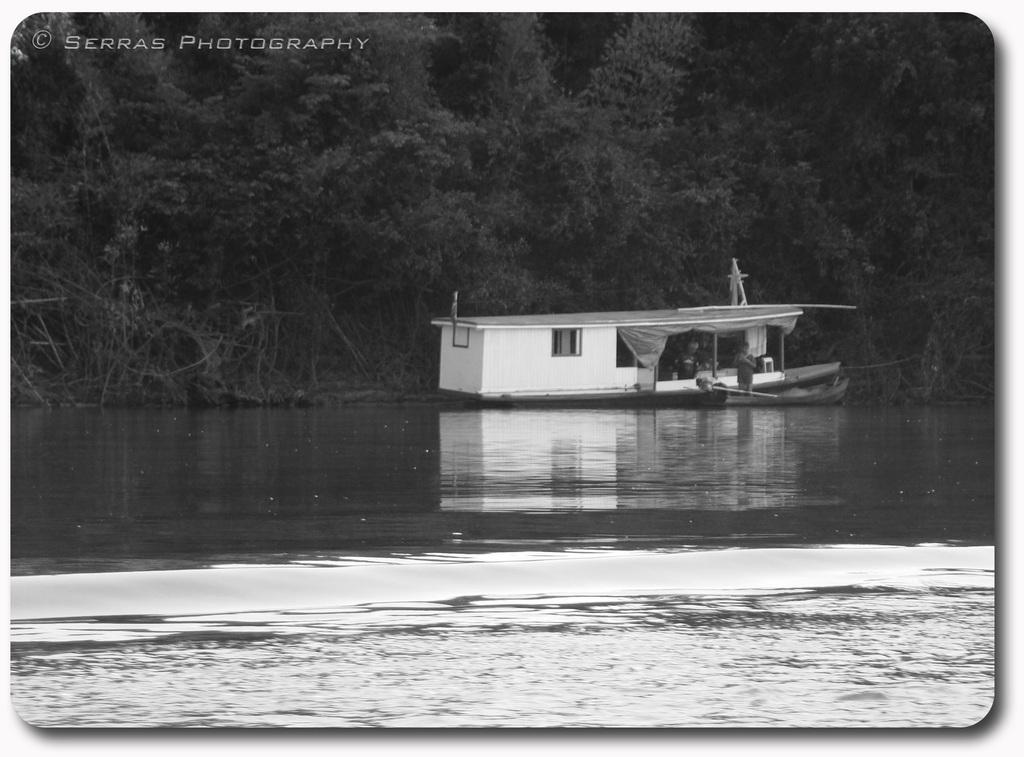What is the main subject of the image? The main subject of the image is a boat. What is the boat doing in the image? The boat is sailing on the water. What can be seen in the background of the image? There are trees in the background of the image. Are there any people on the boat? Yes, there are persons standing in the boat. What type of root can be seen growing from the boat in the image? There is no root growing from the boat in the image. How does the temper of the persons on the boat affect the boat's speed? There is no information about the temper of the persons on the boat, and their temper does not affect the boat's speed. 